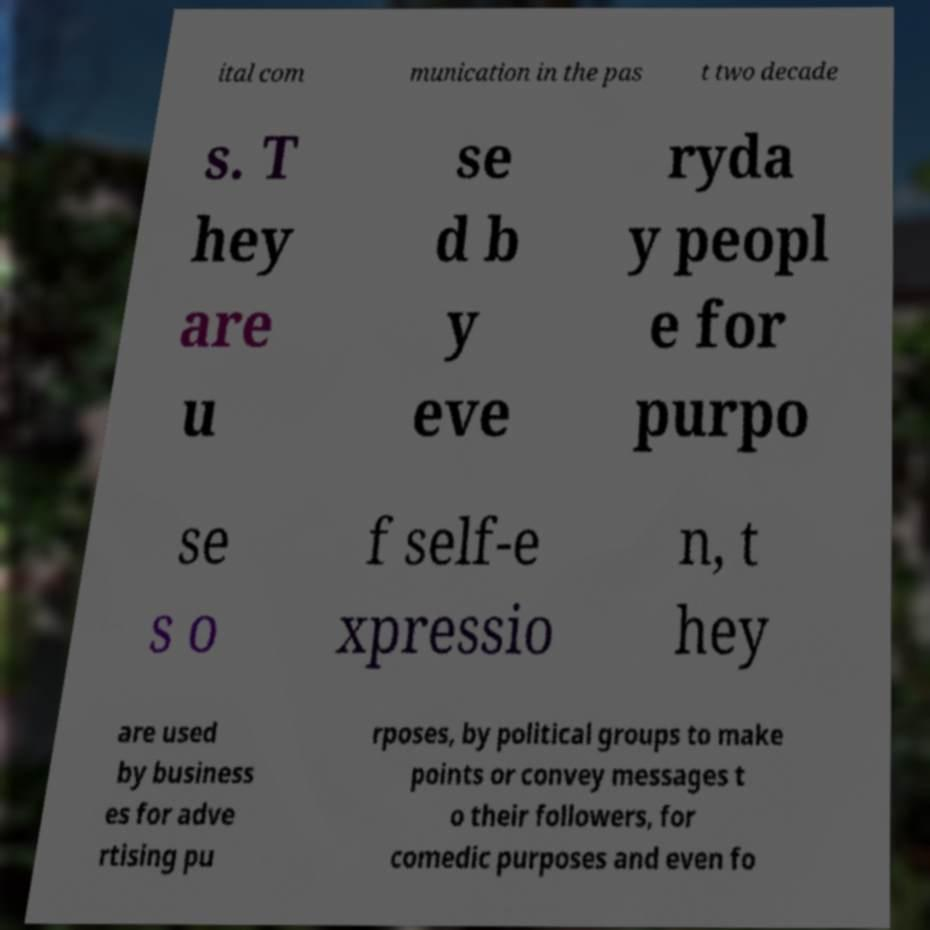What messages or text are displayed in this image? I need them in a readable, typed format. ital com munication in the pas t two decade s. T hey are u se d b y eve ryda y peopl e for purpo se s o f self-e xpressio n, t hey are used by business es for adve rtising pu rposes, by political groups to make points or convey messages t o their followers, for comedic purposes and even fo 